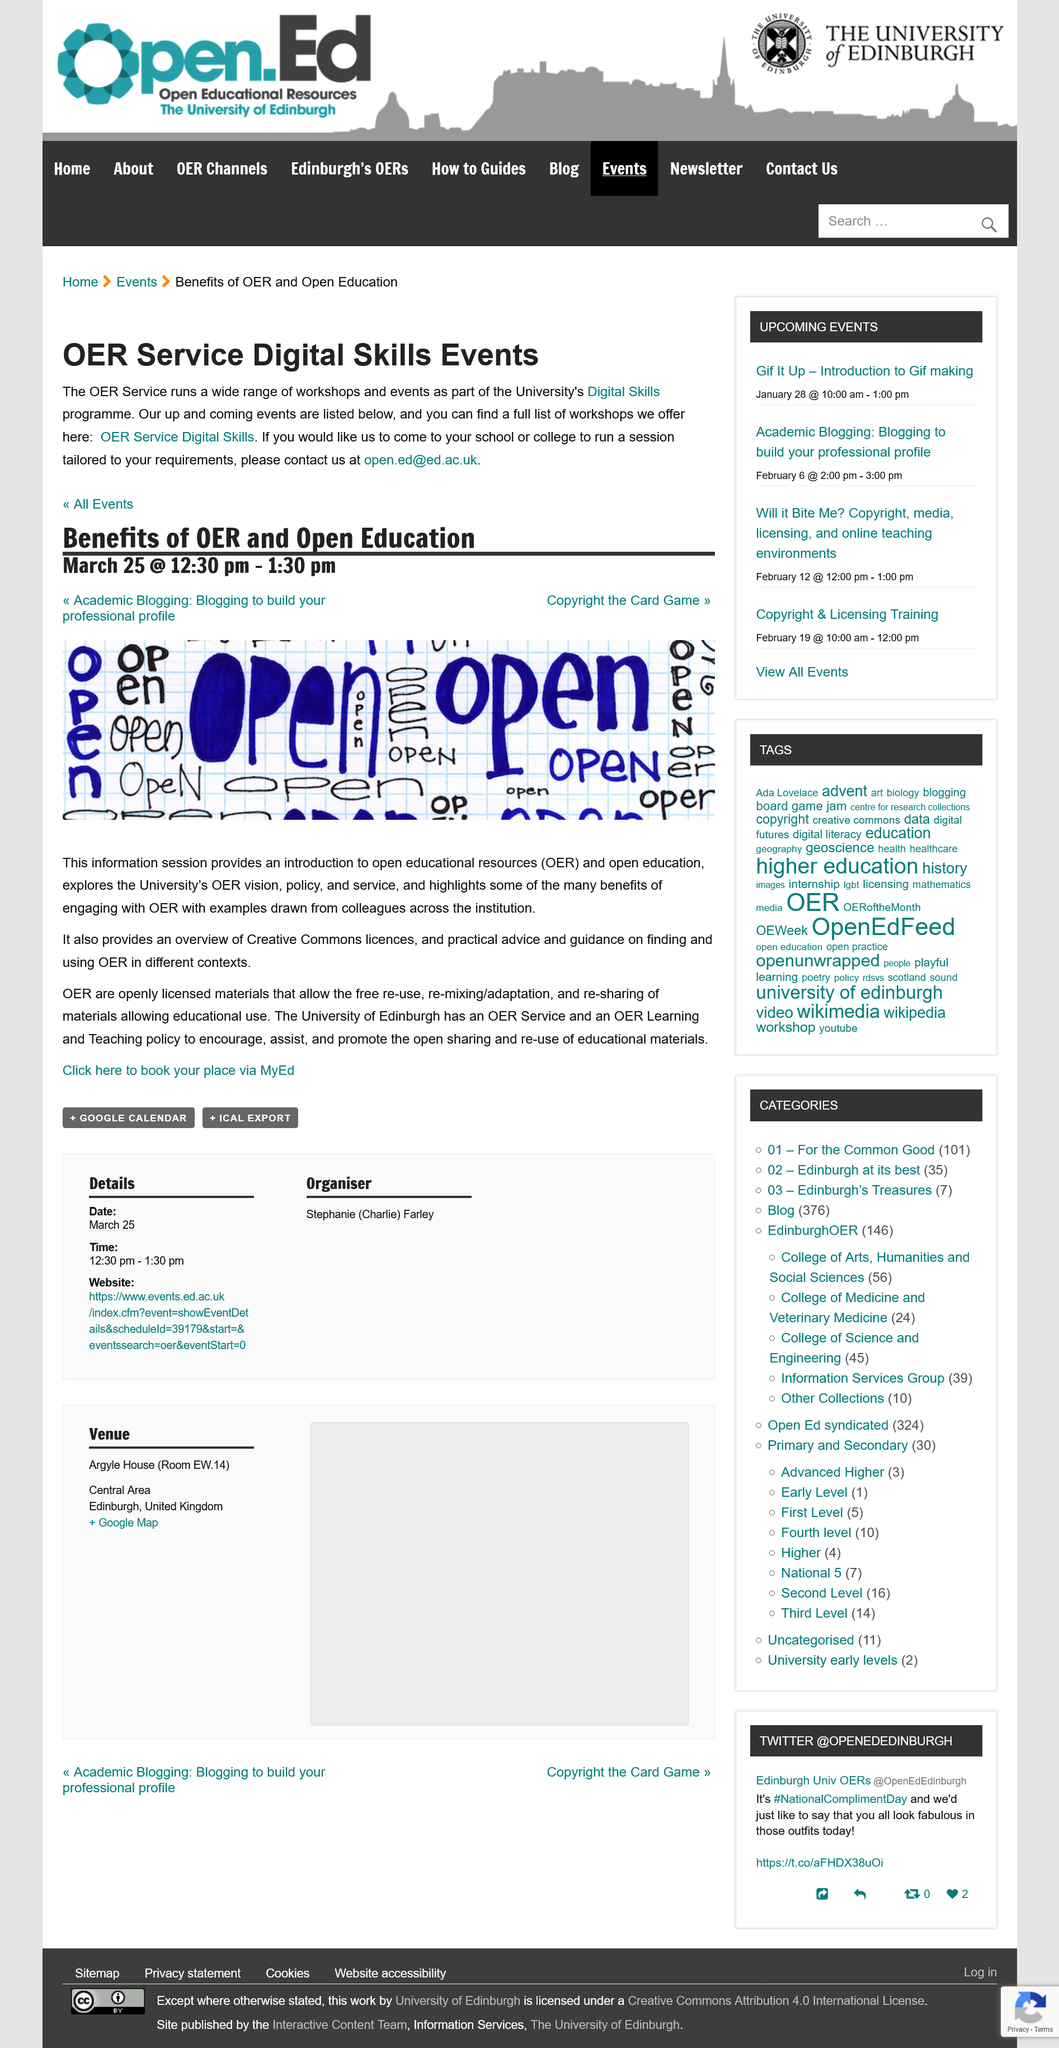Point out several critical features in this image. The University of Edinburgh has an OER Service. The Benefits of OER and Open Education information session was held on March 25, 2023, at 12:30 PM to 1:30 PM. Open educational resources are defined as resources that are made freely available to educators, students, and the public for educational purposes, and are licensed in such a way that they can be used, modified, and shared by others. The acronym OER stands for open educational resources. 